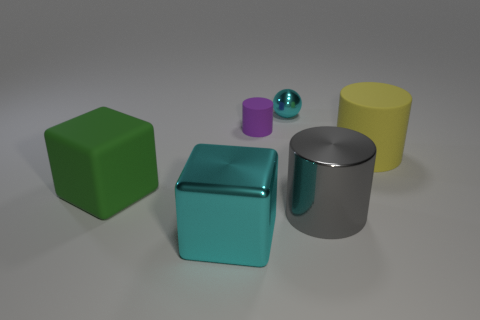What shapes can be seen in the image? The image features a variety of geometric shapes: there's a cube, a cylinder, a smaller cylinder, a sphere, and a cuboid. Which one of them has the most distinct color? The cube stands out with its vibrant green color, which contrasts sharply with the more subdued tones of the other objects. 